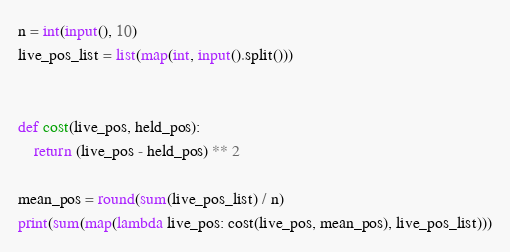Convert code to text. <code><loc_0><loc_0><loc_500><loc_500><_Python_>n = int(input(), 10)
live_pos_list = list(map(int, input().split()))


def cost(live_pos, held_pos):
    return (live_pos - held_pos) ** 2

mean_pos = round(sum(live_pos_list) / n)
print(sum(map(lambda live_pos: cost(live_pos, mean_pos), live_pos_list)))
</code> 